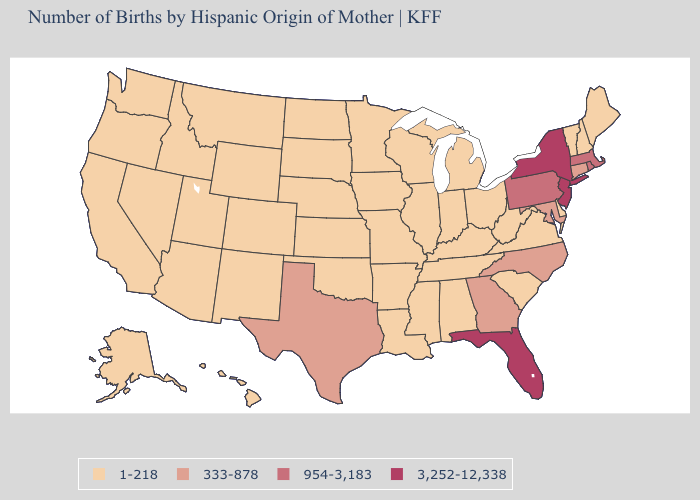Is the legend a continuous bar?
Concise answer only. No. Name the states that have a value in the range 954-3,183?
Short answer required. Massachusetts, Pennsylvania, Rhode Island. What is the value of Oregon?
Write a very short answer. 1-218. Name the states that have a value in the range 1-218?
Concise answer only. Alabama, Alaska, Arizona, Arkansas, California, Colorado, Delaware, Hawaii, Idaho, Illinois, Indiana, Iowa, Kansas, Kentucky, Louisiana, Maine, Michigan, Minnesota, Mississippi, Missouri, Montana, Nebraska, Nevada, New Hampshire, New Mexico, North Dakota, Ohio, Oklahoma, Oregon, South Carolina, South Dakota, Tennessee, Utah, Vermont, Virginia, Washington, West Virginia, Wisconsin, Wyoming. Which states have the highest value in the USA?
Answer briefly. Florida, New Jersey, New York. What is the value of Hawaii?
Concise answer only. 1-218. Is the legend a continuous bar?
Answer briefly. No. Name the states that have a value in the range 1-218?
Concise answer only. Alabama, Alaska, Arizona, Arkansas, California, Colorado, Delaware, Hawaii, Idaho, Illinois, Indiana, Iowa, Kansas, Kentucky, Louisiana, Maine, Michigan, Minnesota, Mississippi, Missouri, Montana, Nebraska, Nevada, New Hampshire, New Mexico, North Dakota, Ohio, Oklahoma, Oregon, South Carolina, South Dakota, Tennessee, Utah, Vermont, Virginia, Washington, West Virginia, Wisconsin, Wyoming. Does North Carolina have a higher value than Oklahoma?
Short answer required. Yes. Does the map have missing data?
Keep it brief. No. What is the lowest value in the USA?
Answer briefly. 1-218. Does Rhode Island have the highest value in the Northeast?
Answer briefly. No. Name the states that have a value in the range 3,252-12,338?
Answer briefly. Florida, New Jersey, New York. Name the states that have a value in the range 333-878?
Concise answer only. Connecticut, Georgia, Maryland, North Carolina, Texas. Name the states that have a value in the range 1-218?
Be succinct. Alabama, Alaska, Arizona, Arkansas, California, Colorado, Delaware, Hawaii, Idaho, Illinois, Indiana, Iowa, Kansas, Kentucky, Louisiana, Maine, Michigan, Minnesota, Mississippi, Missouri, Montana, Nebraska, Nevada, New Hampshire, New Mexico, North Dakota, Ohio, Oklahoma, Oregon, South Carolina, South Dakota, Tennessee, Utah, Vermont, Virginia, Washington, West Virginia, Wisconsin, Wyoming. 